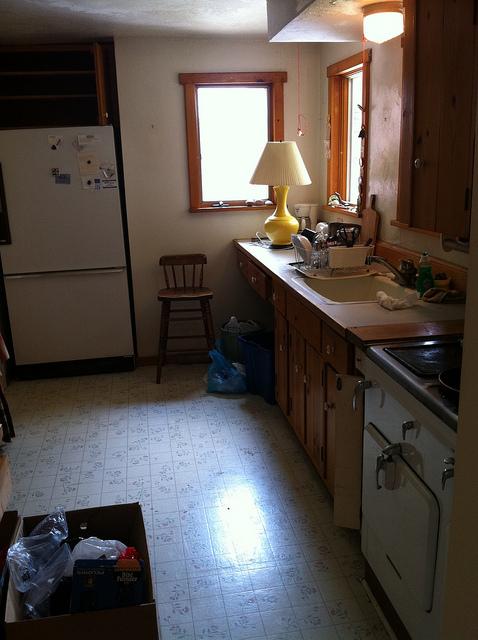Are there dishes in the sink?
Give a very brief answer. No. Is this kitchen large?
Keep it brief. No. Are there any mirrors in this room?
Write a very short answer. No. Are the ceiling lights on or off?
Answer briefly. On. How many cabinet doors are open?
Give a very brief answer. 0. What color are the cabinets?
Write a very short answer. Brown. Where is the artwork?
Concise answer only. Fridge. What is above the sink?
Concise answer only. Cabinet. Did someone clean the kitchen?
Short answer required. Yes. Is this kitchen clean?
Concise answer only. Yes. How many books are on the bookshelves?
Answer briefly. 0. What is located under the window?
Quick response, please. Chair. What type of flooring is visible?
Be succinct. Tile. Is this floor made out of hardwood?
Be succinct. No. How many lights on?
Short answer required. 1. Is the kitchen clean?
Give a very brief answer. Yes. What color is the lamp?
Quick response, please. Yellow. Does the fridge has double door?
Be succinct. No. What kind of room is this?
Short answer required. Kitchen. What room is this?
Quick response, please. Kitchen. What color is the fridge?
Concise answer only. White. Would more light come in if the brown items in the back, over the stove, were opened?
Short answer required. No. How many hanging lights are visible?
Quick response, please. 1. What is over the dining table?
Keep it brief. Lamp. What is on top of the fridge?
Keep it brief. Cabinet. Is this room in use?
Be succinct. No. 